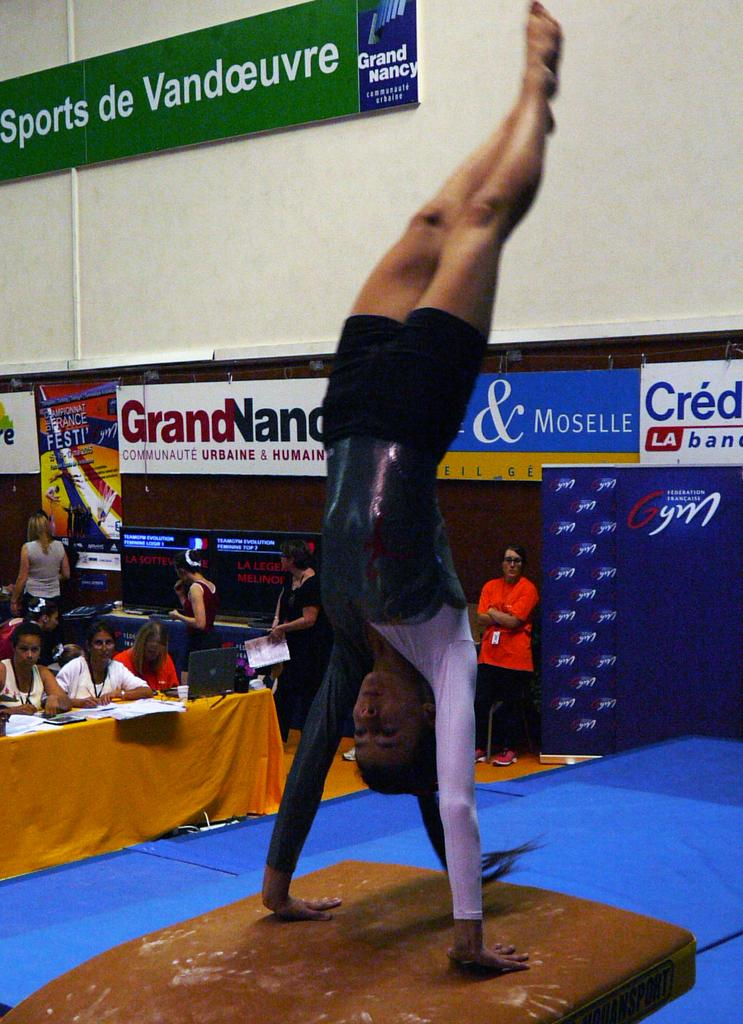What can be seen in the image involving multiple individuals? There is a group of people in the image. What type of furniture is present in the image? There are tables in the image. Are there any decorative elements visible in the image? Yes, there are banners in the image. What type of architectural feature can be seen in the image? There is a wall in the image. Can you describe the attire of one of the individuals in the image? A woman in the front is wearing a black color dress. Where is the cherry located in the image? There is no cherry present in the image. What type of explosive device can be seen in the image? There is no bomb present in the image. 